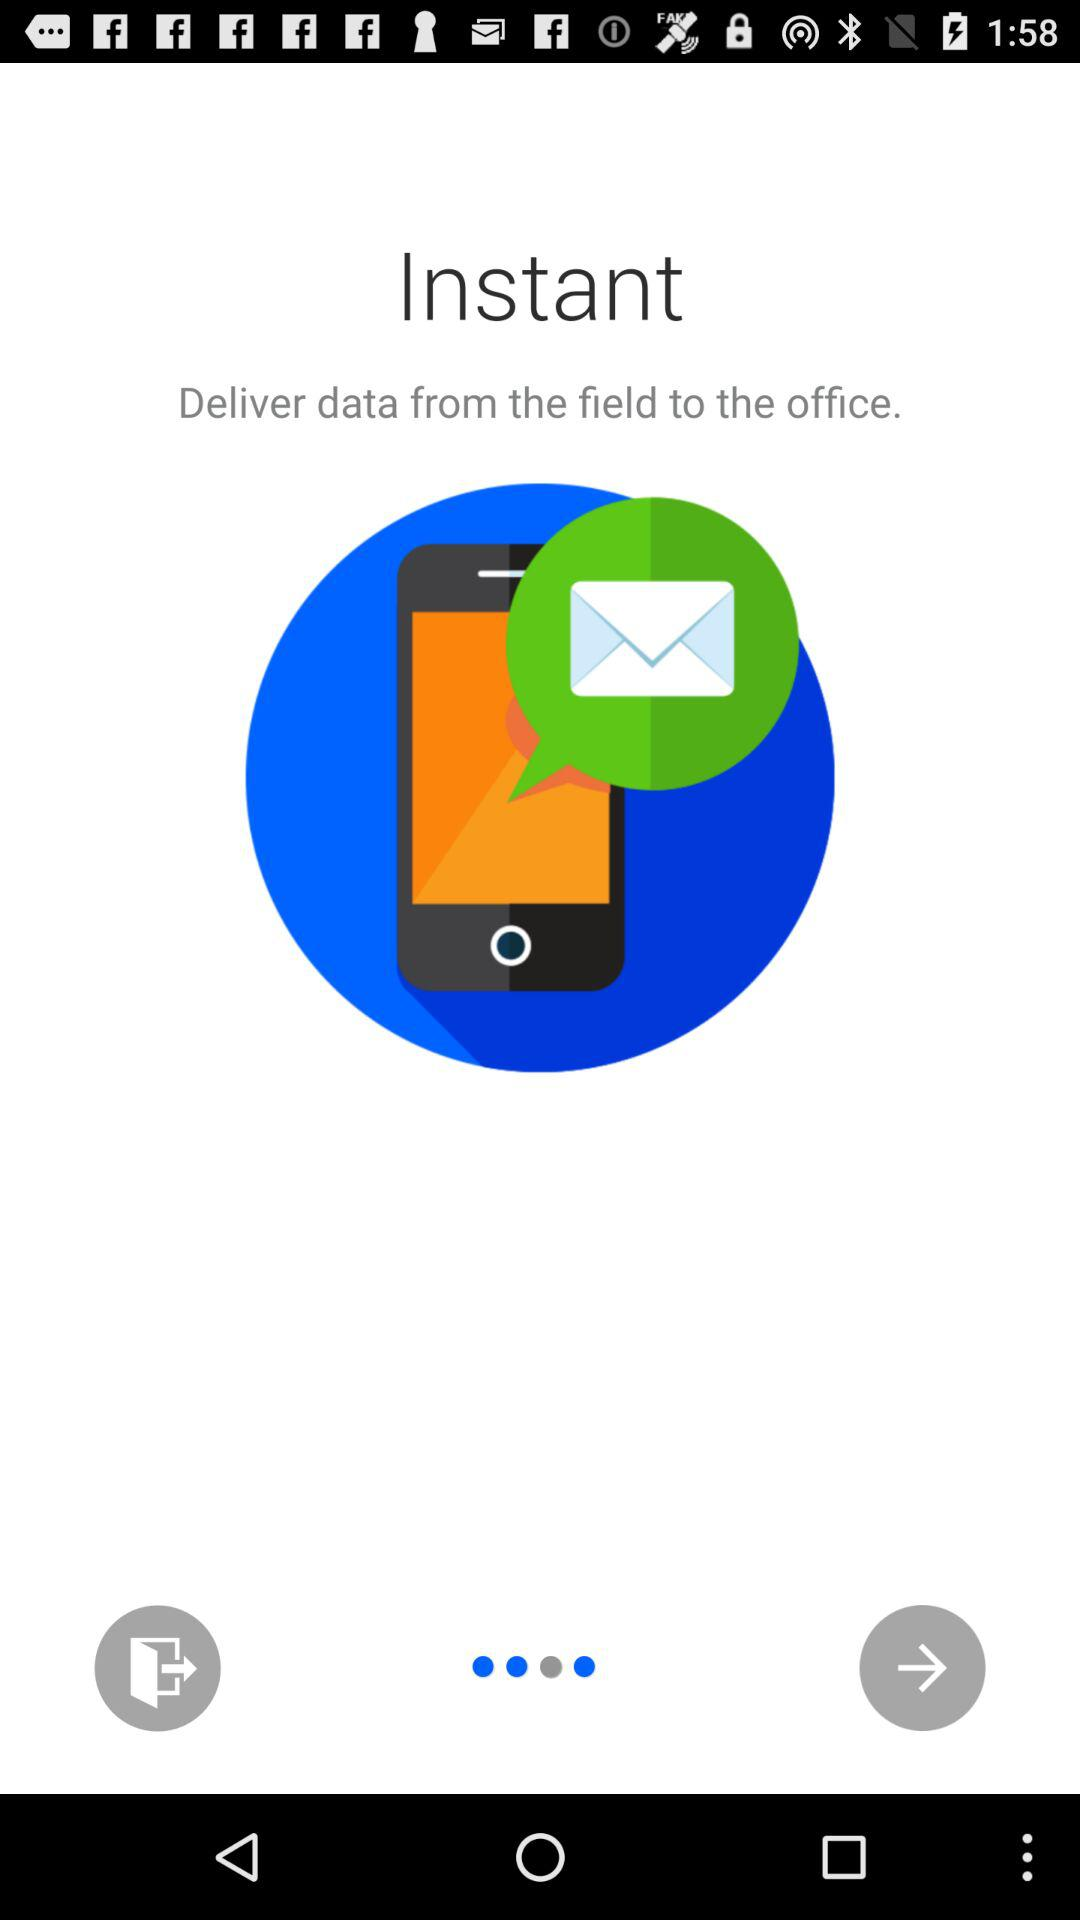What is the application name? The application name is "Instant". 